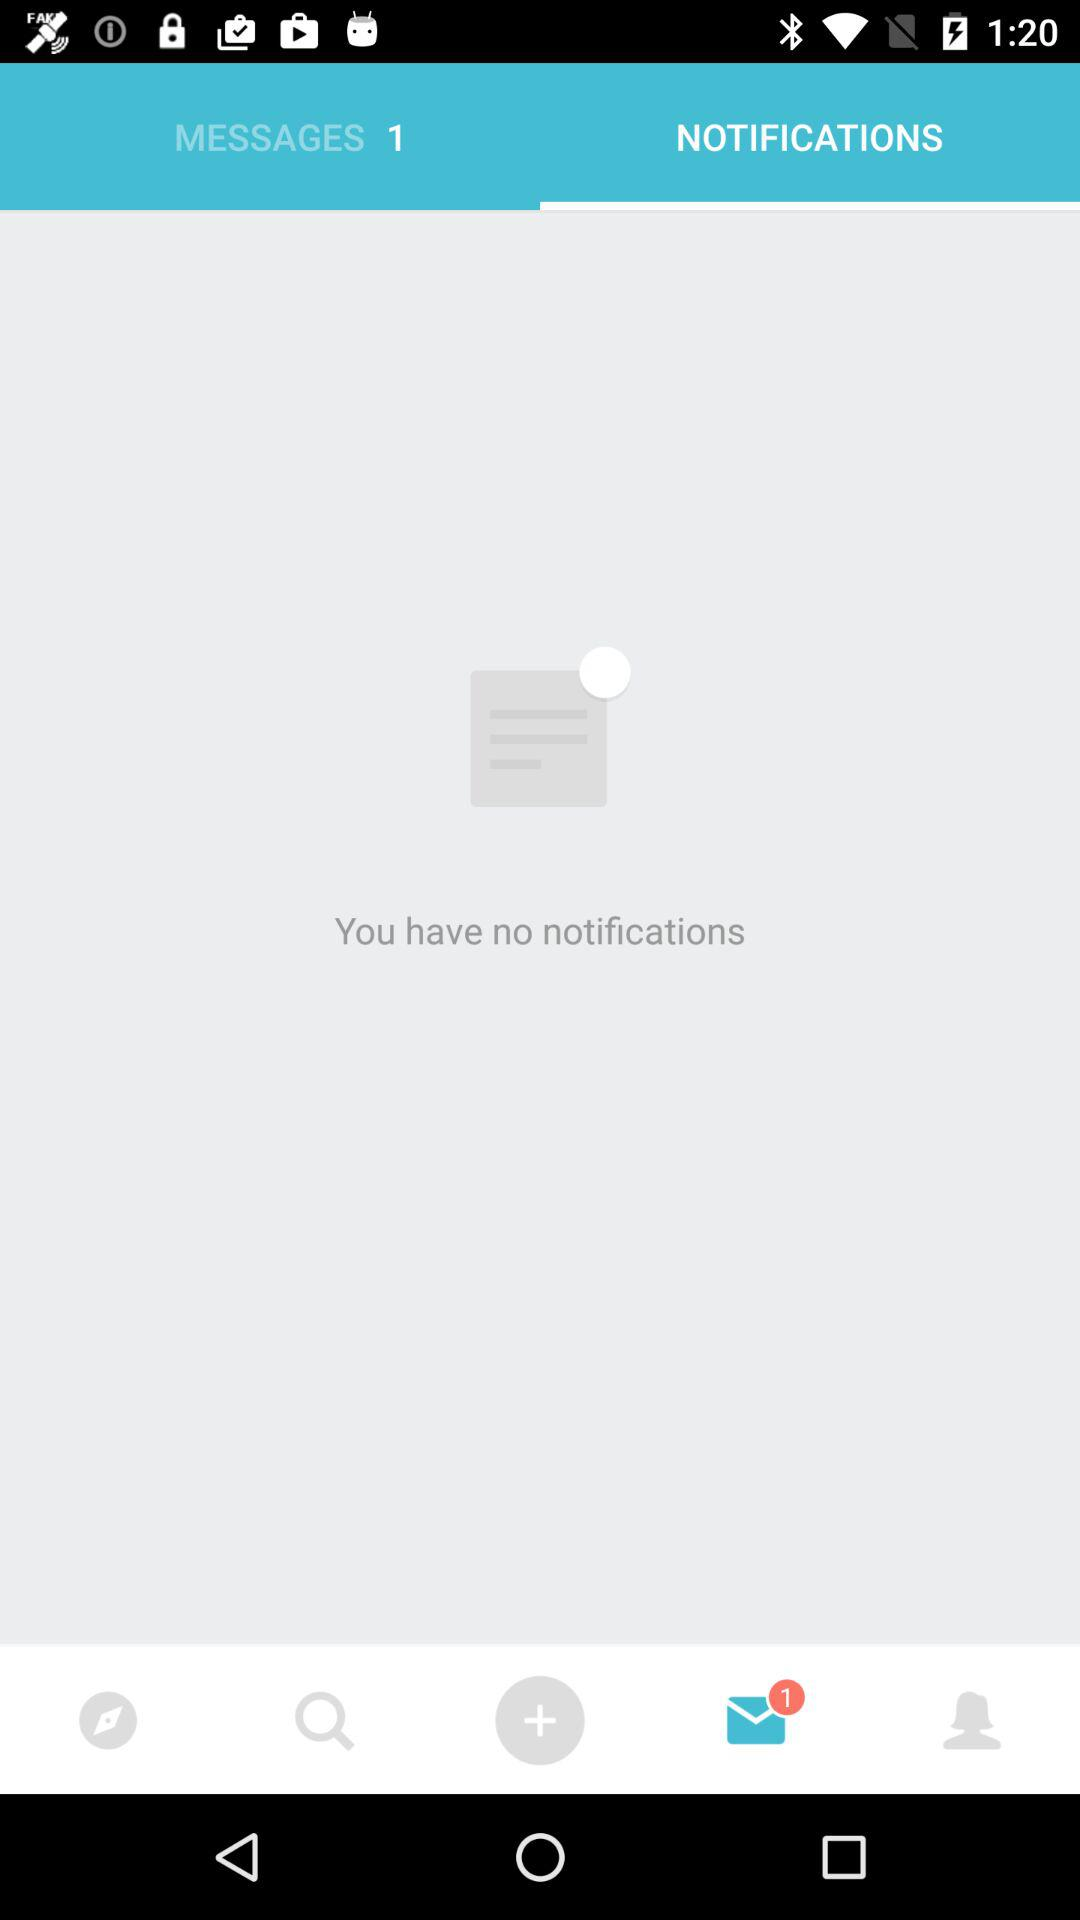How many more messages than notifications does the user have?
Answer the question using a single word or phrase. 1 